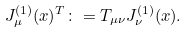<formula> <loc_0><loc_0><loc_500><loc_500>J _ { \mu } ^ { ( 1 ) } ( x ) ^ { T } \colon = T _ { \mu \nu } J _ { \nu } ^ { ( 1 ) } ( x ) .</formula> 